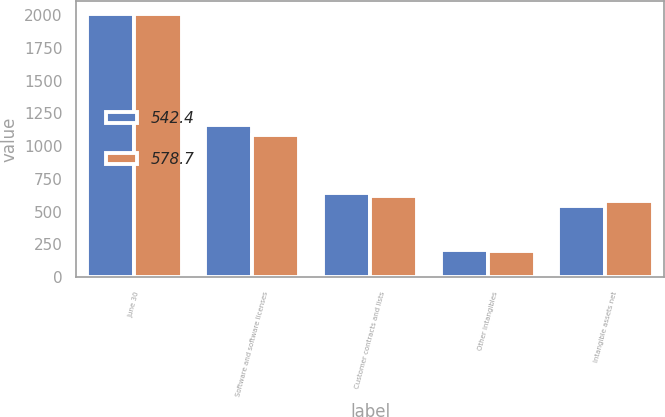<chart> <loc_0><loc_0><loc_500><loc_500><stacked_bar_chart><ecel><fcel>June 30<fcel>Software and software licenses<fcel>Customer contracts and lists<fcel>Other intangibles<fcel>Intangible assets net<nl><fcel>542.4<fcel>2010<fcel>1160<fcel>640.3<fcel>209.5<fcel>542.4<nl><fcel>578.7<fcel>2009<fcel>1085<fcel>621.9<fcel>197.3<fcel>578.7<nl></chart> 